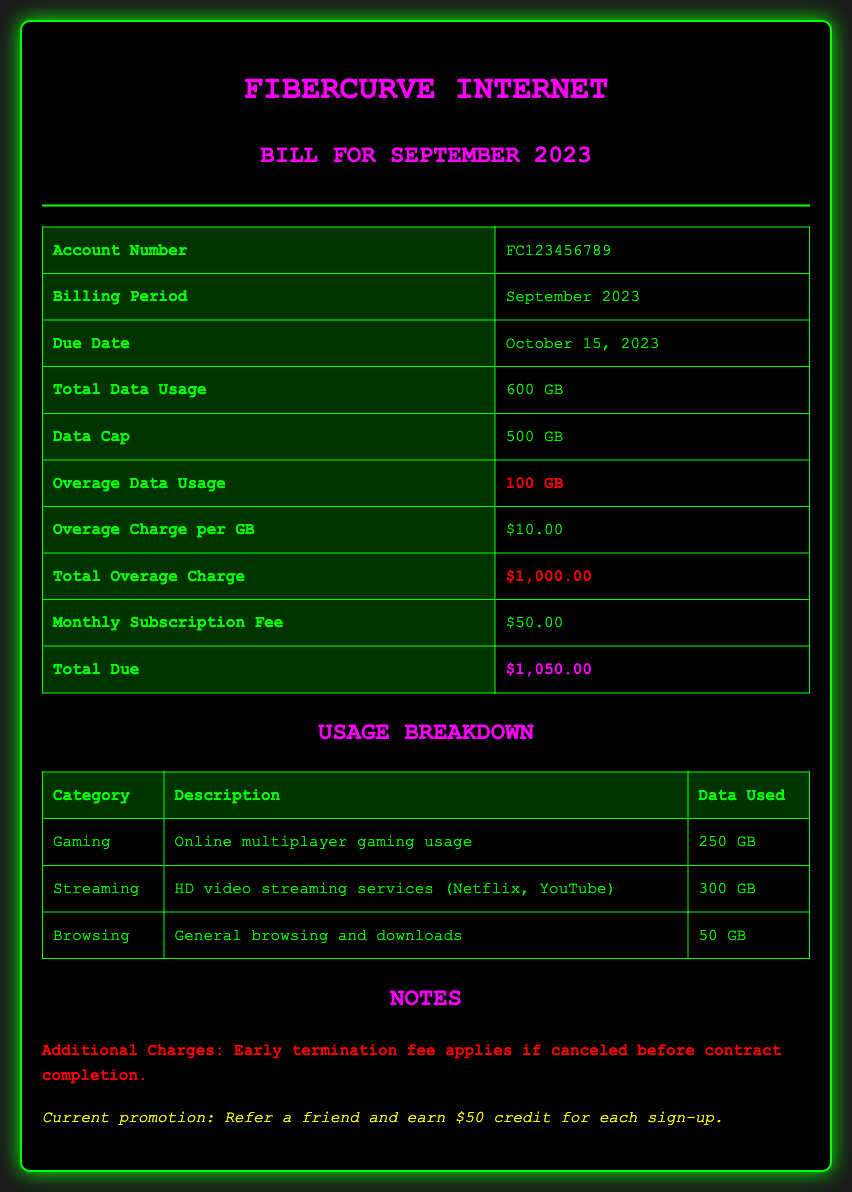What is the account number? The account number is listed in the summary section of the document.
Answer: FC123456789 What is the due date for this bill? The due date is also found in the summary section, indicating when payment is required.
Answer: October 15, 2023 How much is the overage charge per GB? This information appears in the summary and indicates the extra fee for exceeding data limits.
Answer: $10.00 What is the total data usage for September 2023? Total data usage is specifically noted in the summary section of the document.
Answer: 600 GB What is the total due amount? The total due is the final amount that must be paid as per the summary information.
Answer: $1,050.00 How much data was used for online multiplayer gaming? The usage breakdown lists how much data was consumed specifically for gaming.
Answer: 250 GB How much additional charge is incurred for exceeding the data cap? This requires understanding both the total data usage and the data cap.
Answer: $1,000.00 What is the current promotion mentioned? The promotion is found in the notes section and offers a benefit for referrals.
Answer: Refer a friend and earn $50 credit for each sign-up What type of document is this? This document is a transactional document related to billing for an Internet service.
Answer: Internet Service Provider Bill 